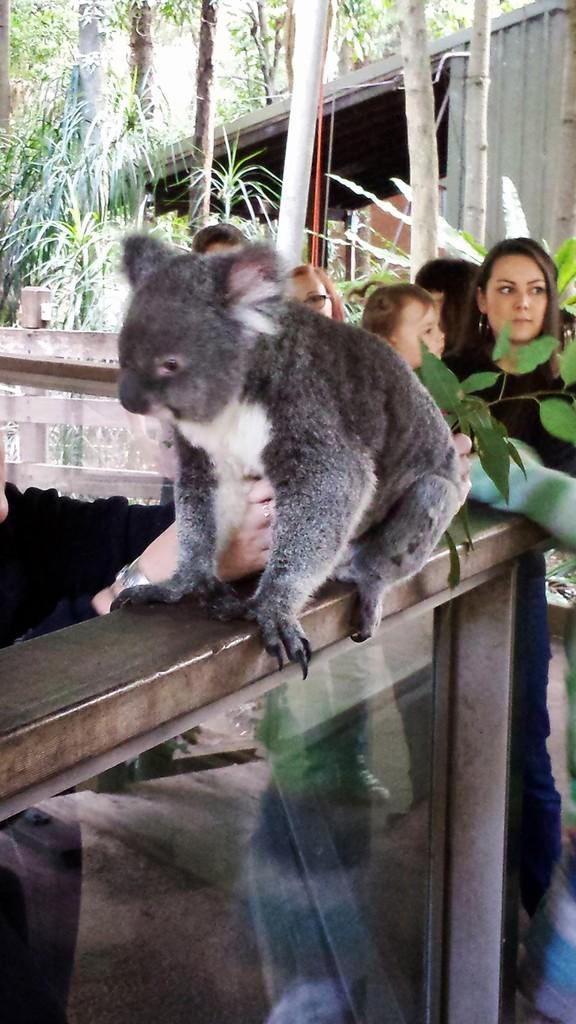What type of animal can be seen in the image? There is an animal in grey color in the image. What is the woman doing in the image? A woman is looking towards the right side of the image. What can be seen on the left side of the image? There are trees on the left side of the image. What type of wax is the woman using to create a sculpture in the image? There is no wax or sculpture present in the image; the woman is simply looking towards the right side. 